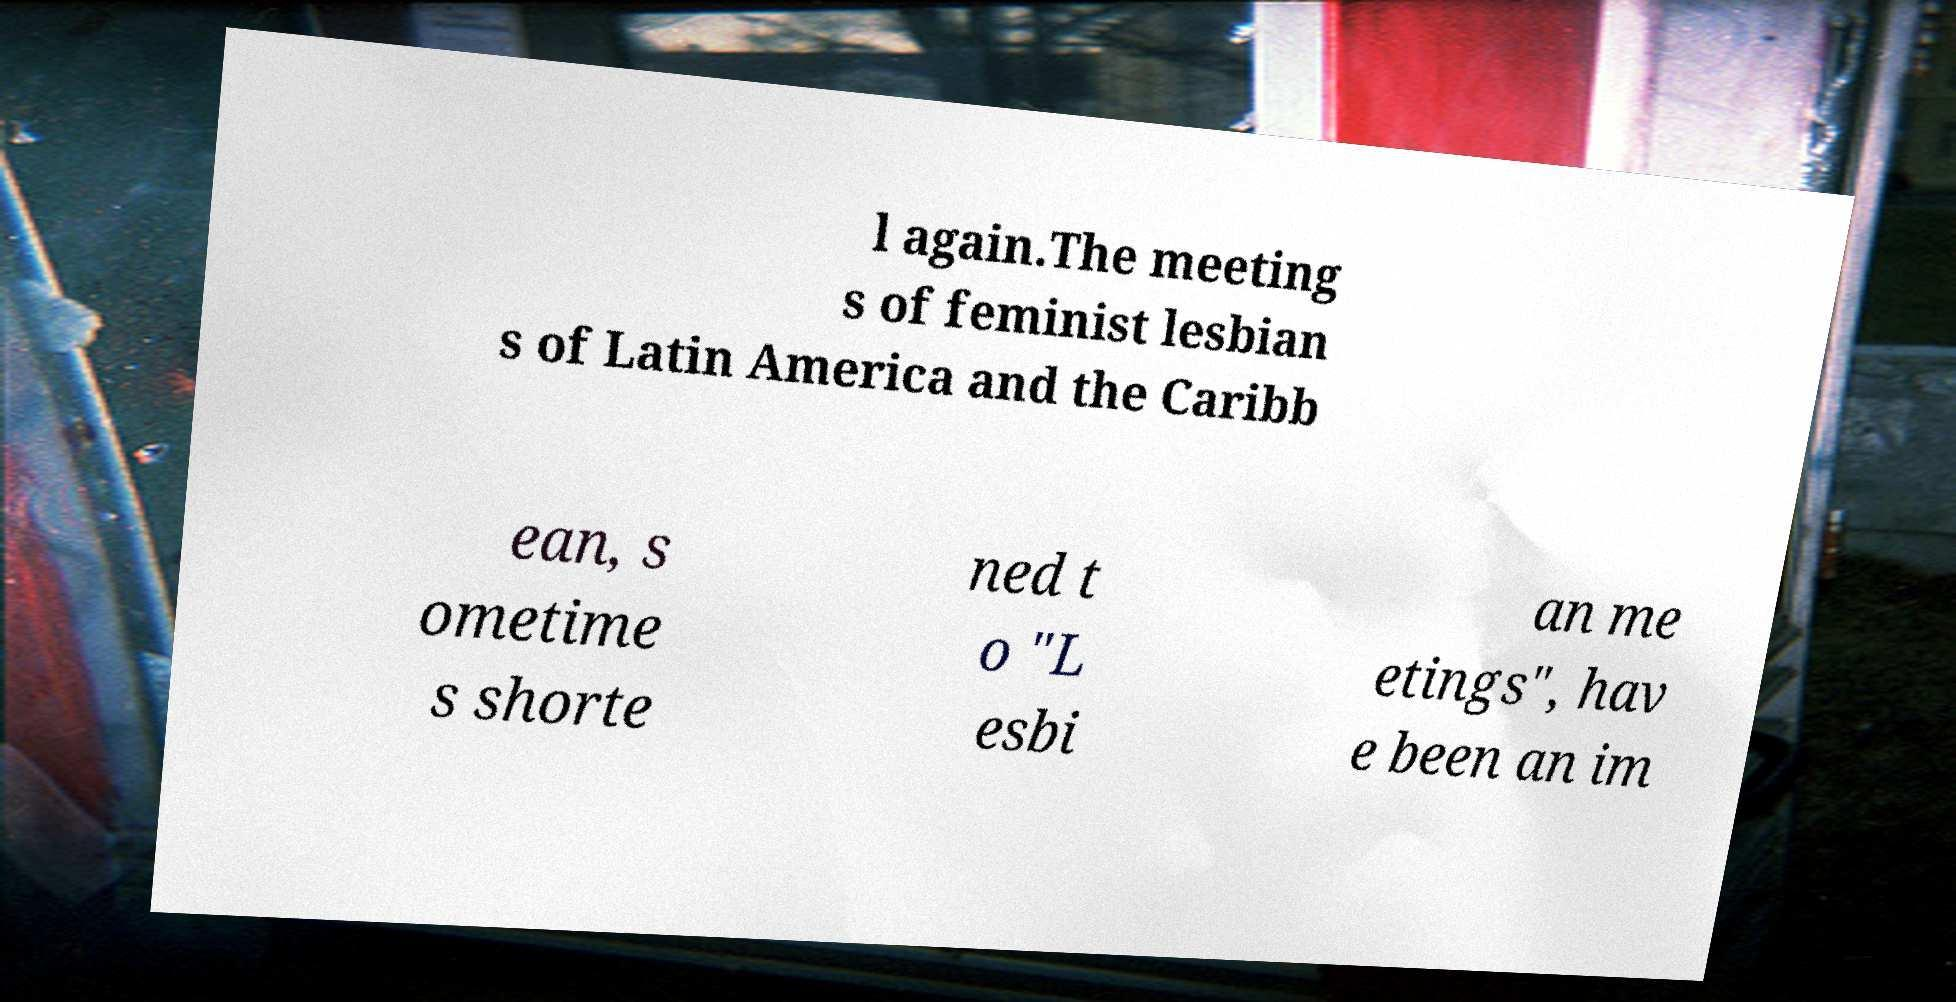There's text embedded in this image that I need extracted. Can you transcribe it verbatim? l again.The meeting s of feminist lesbian s of Latin America and the Caribb ean, s ometime s shorte ned t o "L esbi an me etings", hav e been an im 